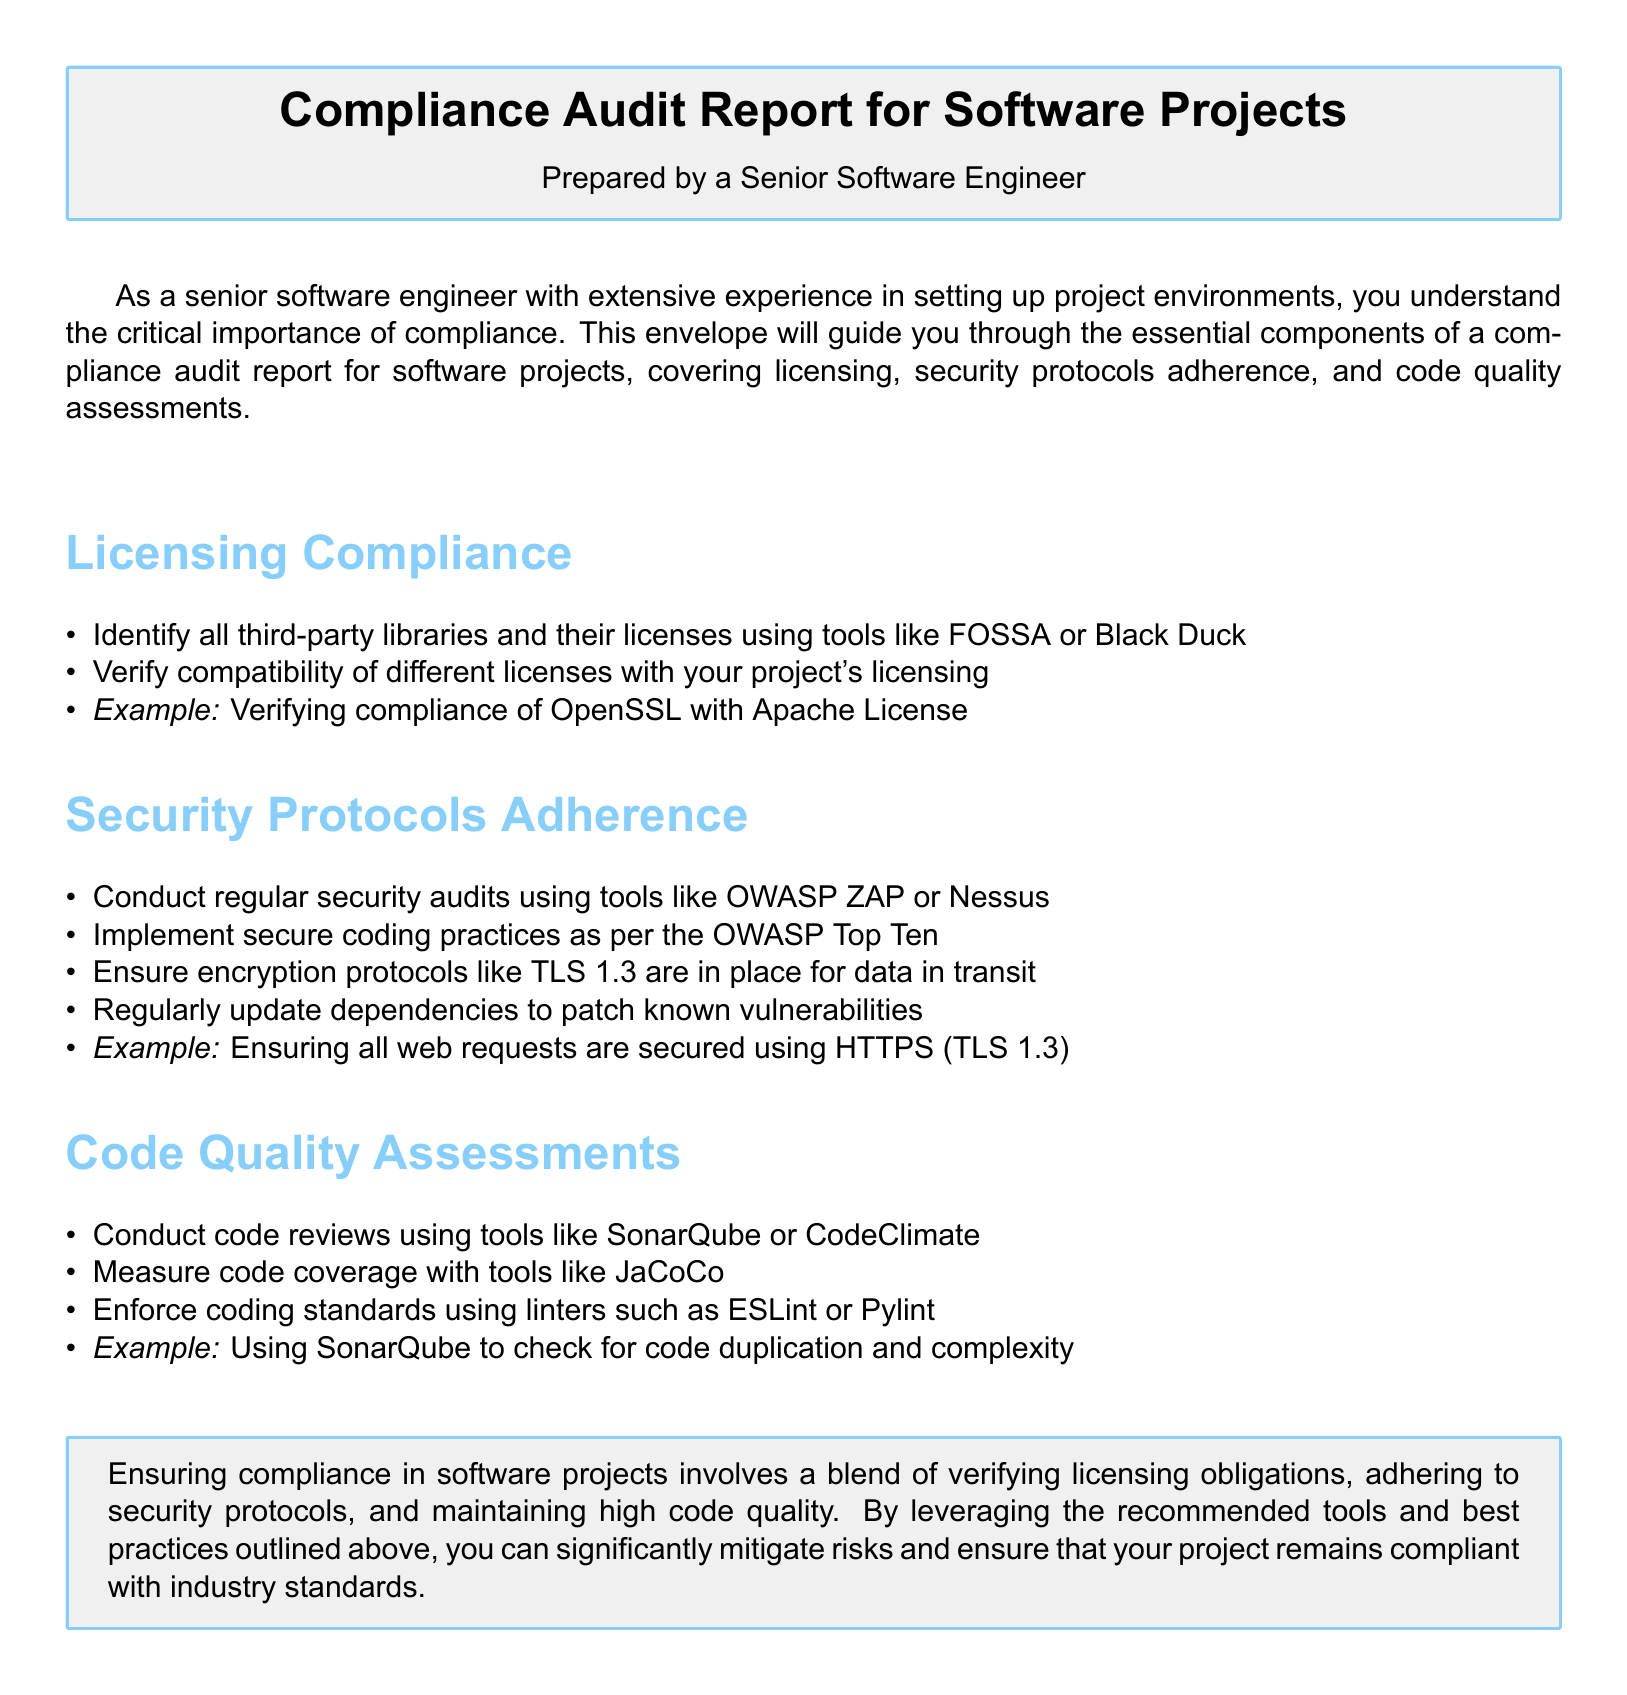What is the title of the document? The title is indicated prominently at the top of the document, stating the purpose and subject matter.
Answer: Compliance Audit Report for Software Projects Who prepared the report? The document mentions the person responsible for preparing the report under the title.
Answer: A Senior Software Engineer What tool is suggested for identifying third-party libraries? The document refers to tools for identifying libraries under the section on licensing compliance.
Answer: FOSSA or Black Duck What security practice is recommended for web requests? The example under security protocols adherence provides a specific practice regarding web requests.
Answer: HTTPS (TLS 1.3) Which tool is suggested for measuring code coverage? The document lists tools under the code quality assessments section for measuring code coverage.
Answer: JaCoCo What is the recommended practice for dependency management? The document emphasizes maintenance of dependencies as part of security adherence.
Answer: Regularly update dependencies What coding standard enforcement tool is mentioned? The document lists linters used for enforcing coding standards under code quality assessments.
Answer: ESLint or Pylint What is the main focus of the compliance audit report? The document summarizes the overarching aim of the compliance audit report.
Answer: Ensuring compliance in software projects How is code duplication assessed in the document? The document mentions a tool used for checking code duplication in the code quality assessments section.
Answer: SonarQube 